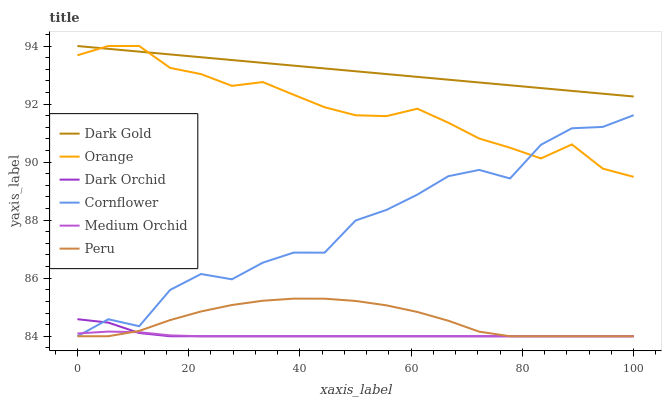Does Medium Orchid have the minimum area under the curve?
Answer yes or no. Yes. Does Dark Gold have the maximum area under the curve?
Answer yes or no. Yes. Does Dark Gold have the minimum area under the curve?
Answer yes or no. No. Does Medium Orchid have the maximum area under the curve?
Answer yes or no. No. Is Dark Gold the smoothest?
Answer yes or no. Yes. Is Cornflower the roughest?
Answer yes or no. Yes. Is Medium Orchid the smoothest?
Answer yes or no. No. Is Medium Orchid the roughest?
Answer yes or no. No. Does Cornflower have the lowest value?
Answer yes or no. Yes. Does Dark Gold have the lowest value?
Answer yes or no. No. Does Orange have the highest value?
Answer yes or no. Yes. Does Medium Orchid have the highest value?
Answer yes or no. No. Is Cornflower less than Dark Gold?
Answer yes or no. Yes. Is Dark Gold greater than Cornflower?
Answer yes or no. Yes. Does Peru intersect Dark Orchid?
Answer yes or no. Yes. Is Peru less than Dark Orchid?
Answer yes or no. No. Is Peru greater than Dark Orchid?
Answer yes or no. No. Does Cornflower intersect Dark Gold?
Answer yes or no. No. 